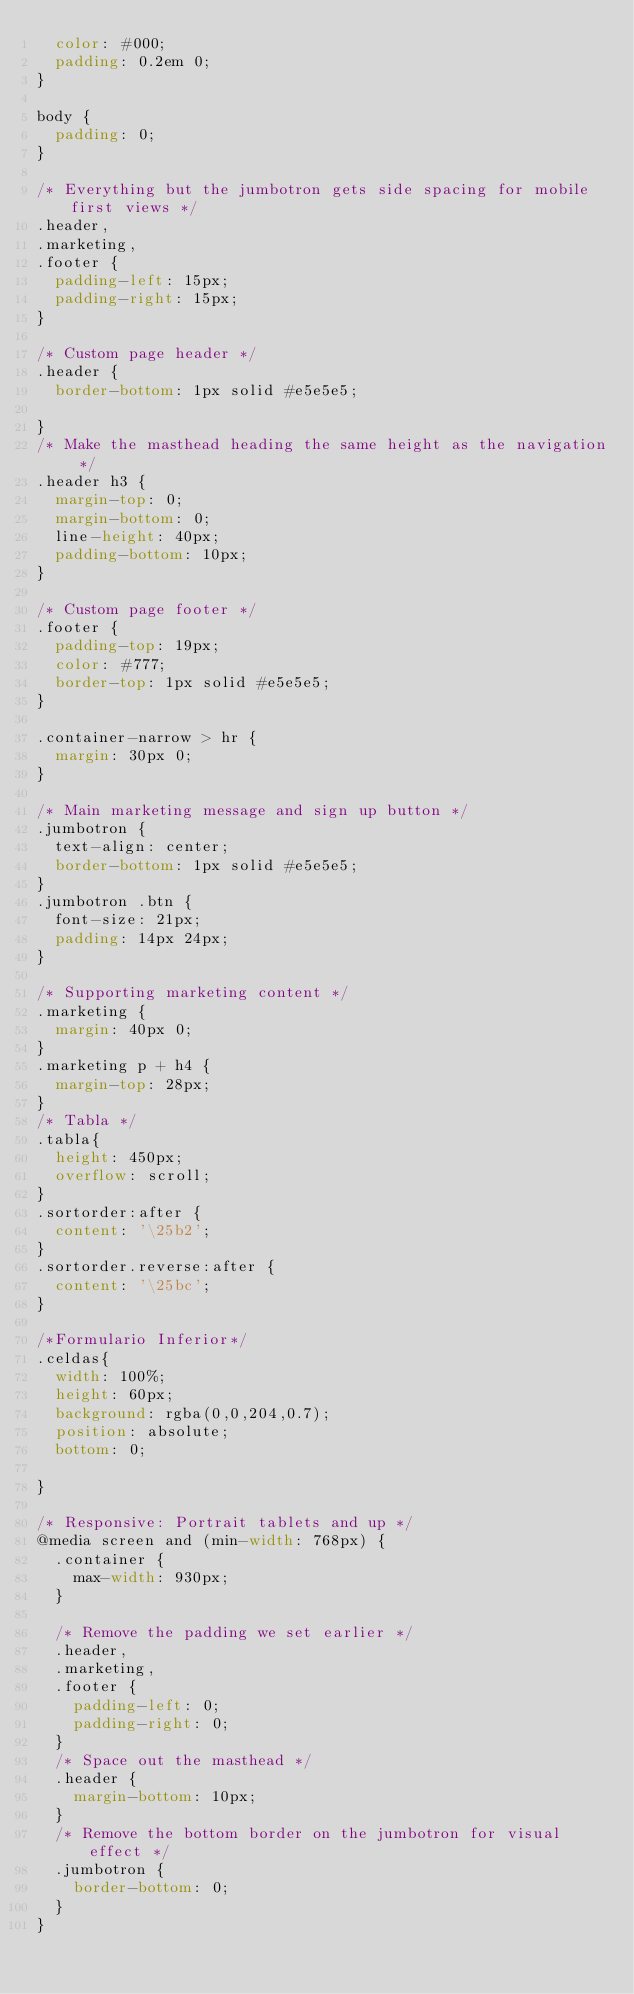<code> <loc_0><loc_0><loc_500><loc_500><_CSS_>  color: #000;
  padding: 0.2em 0;
}

body {
  padding: 0;
}

/* Everything but the jumbotron gets side spacing for mobile first views */
.header,
.marketing,
.footer {
  padding-left: 15px;
  padding-right: 15px;
}

/* Custom page header */
.header {
  border-bottom: 1px solid #e5e5e5;
  
}
/* Make the masthead heading the same height as the navigation */
.header h3 {
  margin-top: 0;
  margin-bottom: 0;
  line-height: 40px;
  padding-bottom: 10px;
}

/* Custom page footer */
.footer {
  padding-top: 19px;
  color: #777;
  border-top: 1px solid #e5e5e5;
}

.container-narrow > hr {
  margin: 30px 0;
}

/* Main marketing message and sign up button */
.jumbotron {
  text-align: center;
  border-bottom: 1px solid #e5e5e5;
}
.jumbotron .btn {
  font-size: 21px;
  padding: 14px 24px;
}

/* Supporting marketing content */
.marketing {
  margin: 40px 0;
}
.marketing p + h4 {
  margin-top: 28px;
}
/* Tabla */
.tabla{
  height: 450px;
  overflow: scroll;
}
.sortorder:after {
  content: '\25b2';
}
.sortorder.reverse:after {
  content: '\25bc';
}

/*Formulario Inferior*/
.celdas{
  width: 100%;
  height: 60px;
  background: rgba(0,0,204,0.7);
  position: absolute;
  bottom: 0;

}

/* Responsive: Portrait tablets and up */
@media screen and (min-width: 768px) {
  .container {
    max-width: 930px;
  }

  /* Remove the padding we set earlier */
  .header,
  .marketing,
  .footer {
    padding-left: 0;
    padding-right: 0;
  }
  /* Space out the masthead */
  .header {
    margin-bottom: 10px;
  }
  /* Remove the bottom border on the jumbotron for visual effect */
  .jumbotron {
    border-bottom: 0;
  }
}
</code> 